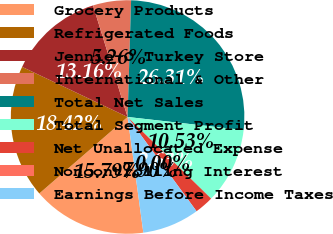<chart> <loc_0><loc_0><loc_500><loc_500><pie_chart><fcel>Grocery Products<fcel>Refrigerated Foods<fcel>Jennie-O Turkey Store<fcel>International & Other<fcel>Total Net Sales<fcel>Total Segment Profit<fcel>Net Unallocated Expense<fcel>Noncontrolling Interest<fcel>Earnings Before Income Taxes<nl><fcel>15.79%<fcel>18.42%<fcel>13.16%<fcel>5.26%<fcel>26.31%<fcel>10.53%<fcel>2.63%<fcel>0.0%<fcel>7.9%<nl></chart> 